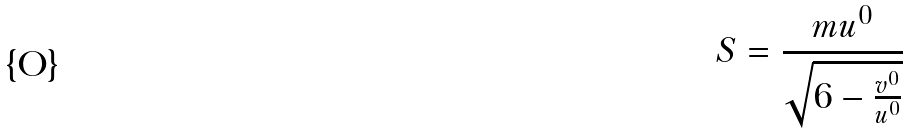<formula> <loc_0><loc_0><loc_500><loc_500>S = \frac { m u ^ { 0 } } { \sqrt { 6 - \frac { v ^ { 0 } } { u ^ { 0 } } } }</formula> 